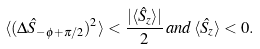<formula> <loc_0><loc_0><loc_500><loc_500>\langle ( \Delta \hat { S } _ { - \phi + \pi / 2 } ) ^ { 2 } \rangle < \frac { | \langle \hat { S } _ { z } \rangle | } { 2 } \, a n d \, \langle \hat { S } _ { z } \rangle < 0 .</formula> 